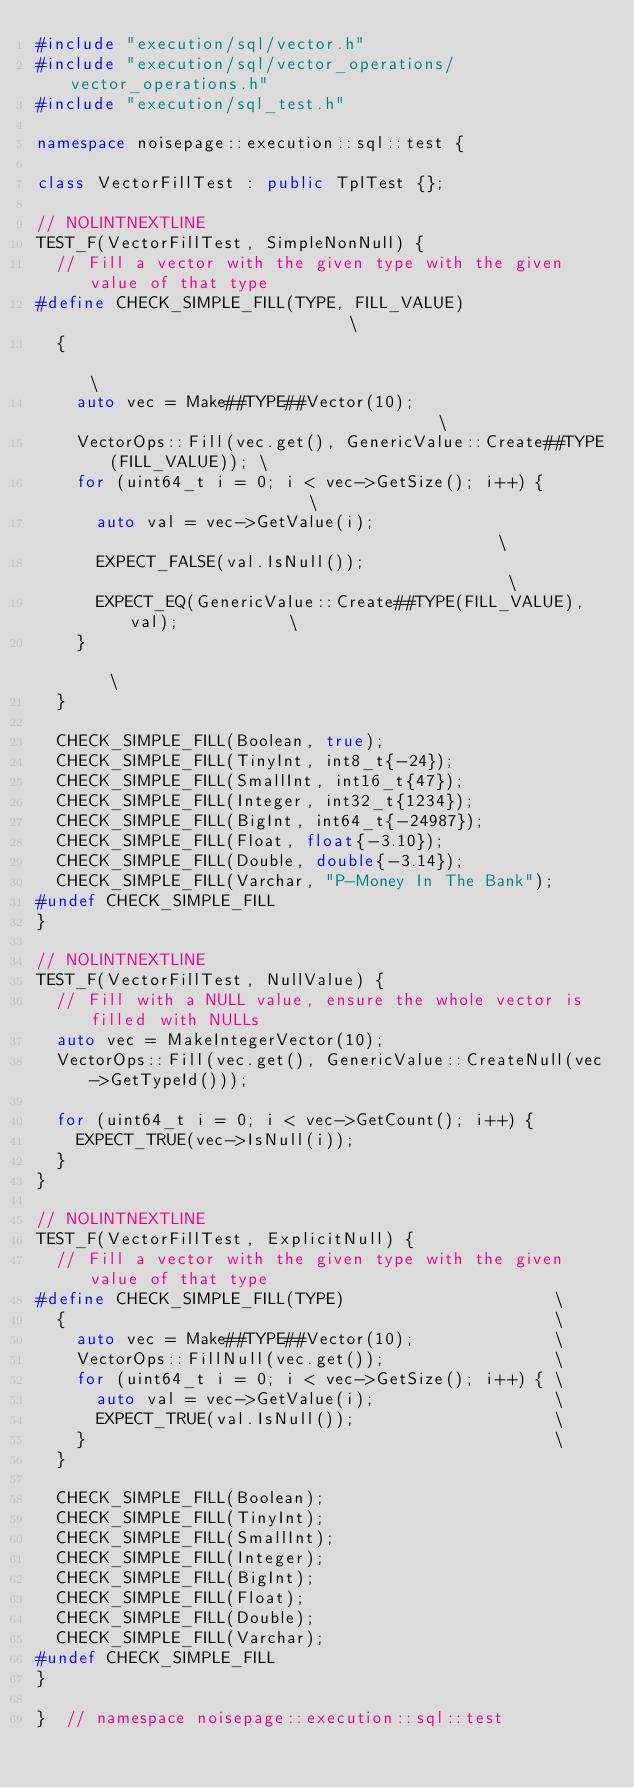Convert code to text. <code><loc_0><loc_0><loc_500><loc_500><_C++_>#include "execution/sql/vector.h"
#include "execution/sql/vector_operations/vector_operations.h"
#include "execution/sql_test.h"

namespace noisepage::execution::sql::test {

class VectorFillTest : public TplTest {};

// NOLINTNEXTLINE
TEST_F(VectorFillTest, SimpleNonNull) {
  // Fill a vector with the given type with the given value of that type
#define CHECK_SIMPLE_FILL(TYPE, FILL_VALUE)                             \
  {                                                                     \
    auto vec = Make##TYPE##Vector(10);                                  \
    VectorOps::Fill(vec.get(), GenericValue::Create##TYPE(FILL_VALUE)); \
    for (uint64_t i = 0; i < vec->GetSize(); i++) {                     \
      auto val = vec->GetValue(i);                                      \
      EXPECT_FALSE(val.IsNull());                                       \
      EXPECT_EQ(GenericValue::Create##TYPE(FILL_VALUE), val);           \
    }                                                                   \
  }

  CHECK_SIMPLE_FILL(Boolean, true);
  CHECK_SIMPLE_FILL(TinyInt, int8_t{-24});
  CHECK_SIMPLE_FILL(SmallInt, int16_t{47});
  CHECK_SIMPLE_FILL(Integer, int32_t{1234});
  CHECK_SIMPLE_FILL(BigInt, int64_t{-24987});
  CHECK_SIMPLE_FILL(Float, float{-3.10});
  CHECK_SIMPLE_FILL(Double, double{-3.14});
  CHECK_SIMPLE_FILL(Varchar, "P-Money In The Bank");
#undef CHECK_SIMPLE_FILL
}

// NOLINTNEXTLINE
TEST_F(VectorFillTest, NullValue) {
  // Fill with a NULL value, ensure the whole vector is filled with NULLs
  auto vec = MakeIntegerVector(10);
  VectorOps::Fill(vec.get(), GenericValue::CreateNull(vec->GetTypeId()));

  for (uint64_t i = 0; i < vec->GetCount(); i++) {
    EXPECT_TRUE(vec->IsNull(i));
  }
}

// NOLINTNEXTLINE
TEST_F(VectorFillTest, ExplicitNull) {
  // Fill a vector with the given type with the given value of that type
#define CHECK_SIMPLE_FILL(TYPE)                     \
  {                                                 \
    auto vec = Make##TYPE##Vector(10);              \
    VectorOps::FillNull(vec.get());                 \
    for (uint64_t i = 0; i < vec->GetSize(); i++) { \
      auto val = vec->GetValue(i);                  \
      EXPECT_TRUE(val.IsNull());                    \
    }                                               \
  }

  CHECK_SIMPLE_FILL(Boolean);
  CHECK_SIMPLE_FILL(TinyInt);
  CHECK_SIMPLE_FILL(SmallInt);
  CHECK_SIMPLE_FILL(Integer);
  CHECK_SIMPLE_FILL(BigInt);
  CHECK_SIMPLE_FILL(Float);
  CHECK_SIMPLE_FILL(Double);
  CHECK_SIMPLE_FILL(Varchar);
#undef CHECK_SIMPLE_FILL
}

}  // namespace noisepage::execution::sql::test
</code> 